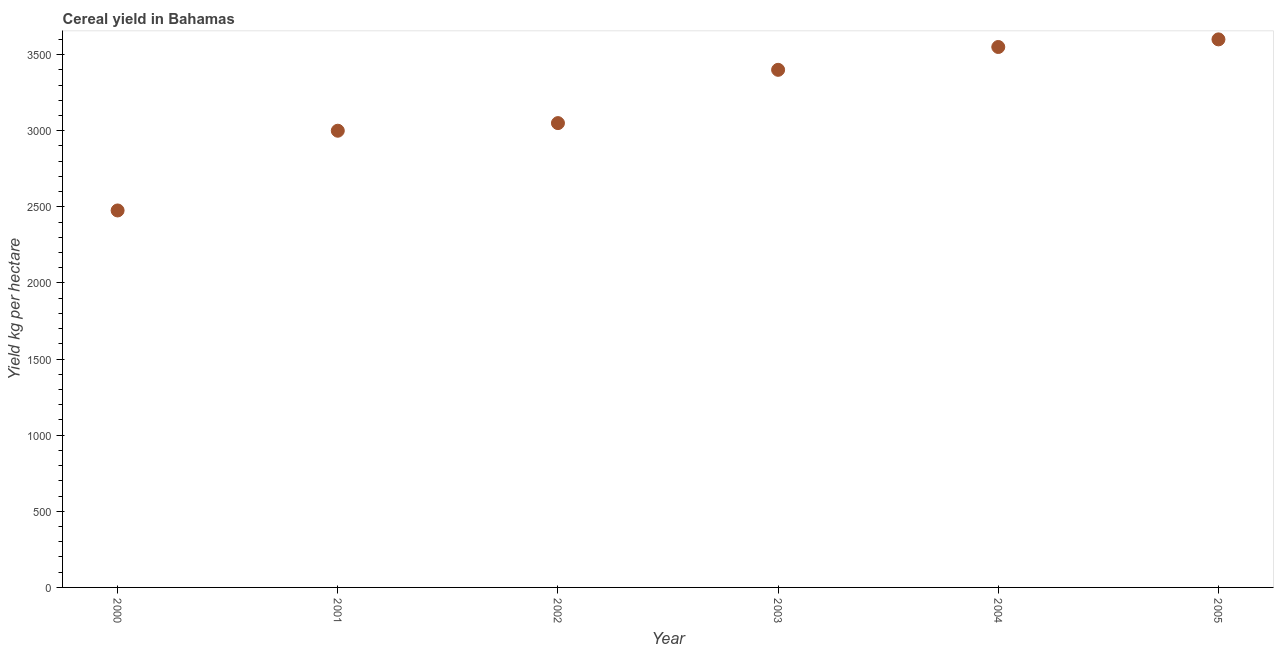What is the cereal yield in 2000?
Your answer should be compact. 2476.19. Across all years, what is the maximum cereal yield?
Keep it short and to the point. 3600. Across all years, what is the minimum cereal yield?
Your answer should be compact. 2476.19. In which year was the cereal yield minimum?
Your response must be concise. 2000. What is the sum of the cereal yield?
Ensure brevity in your answer.  1.91e+04. What is the difference between the cereal yield in 2002 and 2004?
Offer a terse response. -500. What is the average cereal yield per year?
Make the answer very short. 3179.37. What is the median cereal yield?
Your response must be concise. 3225. In how many years, is the cereal yield greater than 300 kg per hectare?
Give a very brief answer. 6. Do a majority of the years between 2005 and 2002 (inclusive) have cereal yield greater than 600 kg per hectare?
Your answer should be compact. Yes. What is the ratio of the cereal yield in 2002 to that in 2003?
Provide a short and direct response. 0.9. Is the cereal yield in 2000 less than that in 2001?
Offer a terse response. Yes. Is the difference between the cereal yield in 2001 and 2002 greater than the difference between any two years?
Make the answer very short. No. What is the difference between the highest and the lowest cereal yield?
Provide a succinct answer. 1123.81. How many dotlines are there?
Keep it short and to the point. 1. How many years are there in the graph?
Make the answer very short. 6. What is the difference between two consecutive major ticks on the Y-axis?
Your answer should be compact. 500. Are the values on the major ticks of Y-axis written in scientific E-notation?
Your answer should be very brief. No. What is the title of the graph?
Offer a very short reply. Cereal yield in Bahamas. What is the label or title of the Y-axis?
Provide a succinct answer. Yield kg per hectare. What is the Yield kg per hectare in 2000?
Give a very brief answer. 2476.19. What is the Yield kg per hectare in 2001?
Make the answer very short. 3000. What is the Yield kg per hectare in 2002?
Your answer should be compact. 3050. What is the Yield kg per hectare in 2003?
Provide a short and direct response. 3400. What is the Yield kg per hectare in 2004?
Ensure brevity in your answer.  3550. What is the Yield kg per hectare in 2005?
Your answer should be compact. 3600. What is the difference between the Yield kg per hectare in 2000 and 2001?
Your answer should be very brief. -523.81. What is the difference between the Yield kg per hectare in 2000 and 2002?
Your answer should be very brief. -573.81. What is the difference between the Yield kg per hectare in 2000 and 2003?
Your response must be concise. -923.81. What is the difference between the Yield kg per hectare in 2000 and 2004?
Offer a terse response. -1073.81. What is the difference between the Yield kg per hectare in 2000 and 2005?
Your answer should be very brief. -1123.81. What is the difference between the Yield kg per hectare in 2001 and 2003?
Make the answer very short. -400. What is the difference between the Yield kg per hectare in 2001 and 2004?
Your answer should be compact. -550. What is the difference between the Yield kg per hectare in 2001 and 2005?
Ensure brevity in your answer.  -600. What is the difference between the Yield kg per hectare in 2002 and 2003?
Offer a very short reply. -350. What is the difference between the Yield kg per hectare in 2002 and 2004?
Offer a very short reply. -500. What is the difference between the Yield kg per hectare in 2002 and 2005?
Your answer should be compact. -550. What is the difference between the Yield kg per hectare in 2003 and 2004?
Make the answer very short. -150. What is the difference between the Yield kg per hectare in 2003 and 2005?
Your response must be concise. -200. What is the ratio of the Yield kg per hectare in 2000 to that in 2001?
Give a very brief answer. 0.82. What is the ratio of the Yield kg per hectare in 2000 to that in 2002?
Your answer should be compact. 0.81. What is the ratio of the Yield kg per hectare in 2000 to that in 2003?
Provide a succinct answer. 0.73. What is the ratio of the Yield kg per hectare in 2000 to that in 2004?
Ensure brevity in your answer.  0.7. What is the ratio of the Yield kg per hectare in 2000 to that in 2005?
Make the answer very short. 0.69. What is the ratio of the Yield kg per hectare in 2001 to that in 2002?
Your answer should be very brief. 0.98. What is the ratio of the Yield kg per hectare in 2001 to that in 2003?
Your answer should be very brief. 0.88. What is the ratio of the Yield kg per hectare in 2001 to that in 2004?
Make the answer very short. 0.84. What is the ratio of the Yield kg per hectare in 2001 to that in 2005?
Your answer should be very brief. 0.83. What is the ratio of the Yield kg per hectare in 2002 to that in 2003?
Provide a short and direct response. 0.9. What is the ratio of the Yield kg per hectare in 2002 to that in 2004?
Your response must be concise. 0.86. What is the ratio of the Yield kg per hectare in 2002 to that in 2005?
Provide a succinct answer. 0.85. What is the ratio of the Yield kg per hectare in 2003 to that in 2004?
Give a very brief answer. 0.96. What is the ratio of the Yield kg per hectare in 2003 to that in 2005?
Ensure brevity in your answer.  0.94. What is the ratio of the Yield kg per hectare in 2004 to that in 2005?
Make the answer very short. 0.99. 